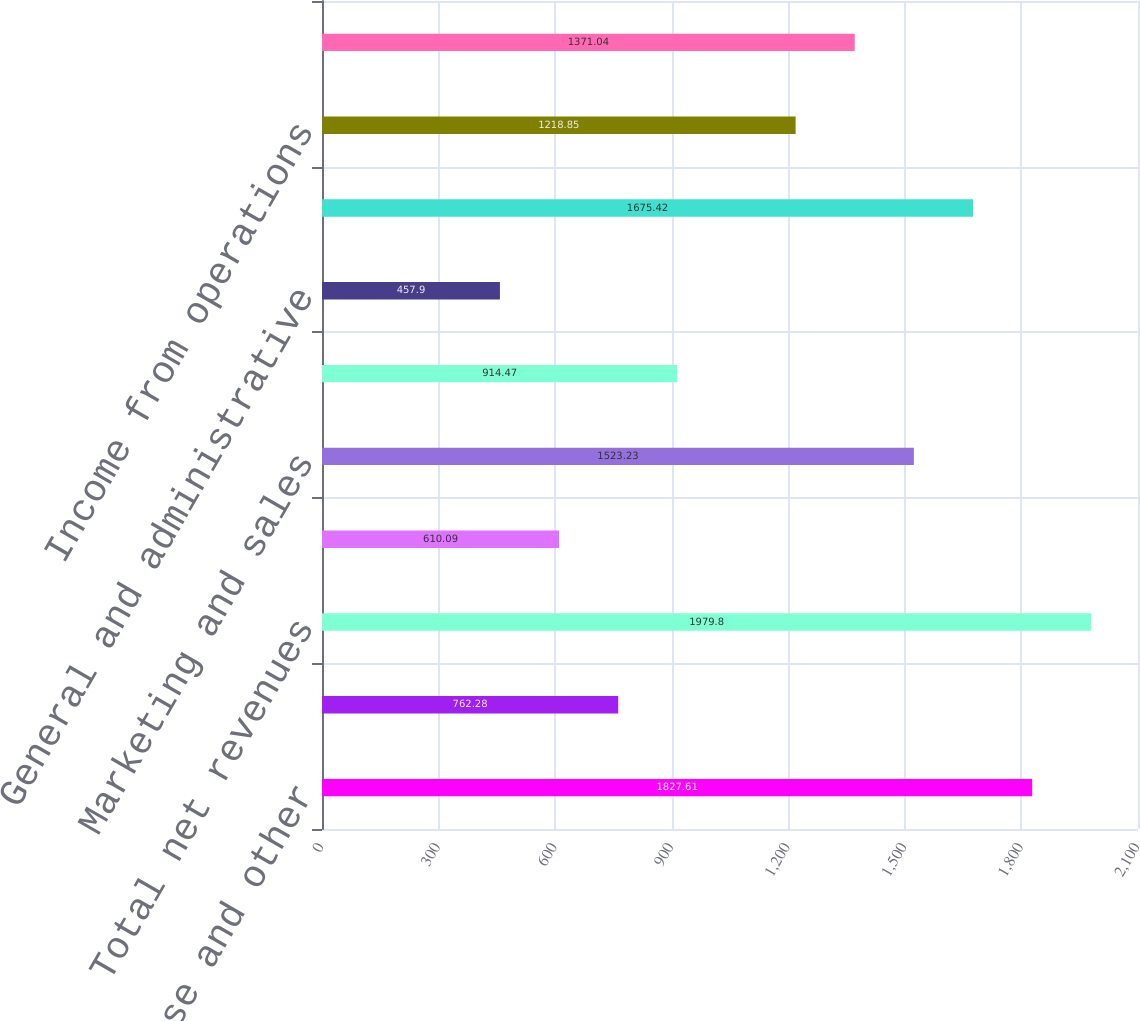Convert chart to OTSL. <chart><loc_0><loc_0><loc_500><loc_500><bar_chart><fcel>License and other<fcel>Maintenance<fcel>Total net revenues<fcel>Cost of license and other<fcel>Marketing and sales<fcel>Research and development<fcel>General and administrative<fcel>Total costs and expenses<fcel>Income from operations<fcel>Income before income taxes<nl><fcel>1827.61<fcel>762.28<fcel>1979.8<fcel>610.09<fcel>1523.23<fcel>914.47<fcel>457.9<fcel>1675.42<fcel>1218.85<fcel>1371.04<nl></chart> 